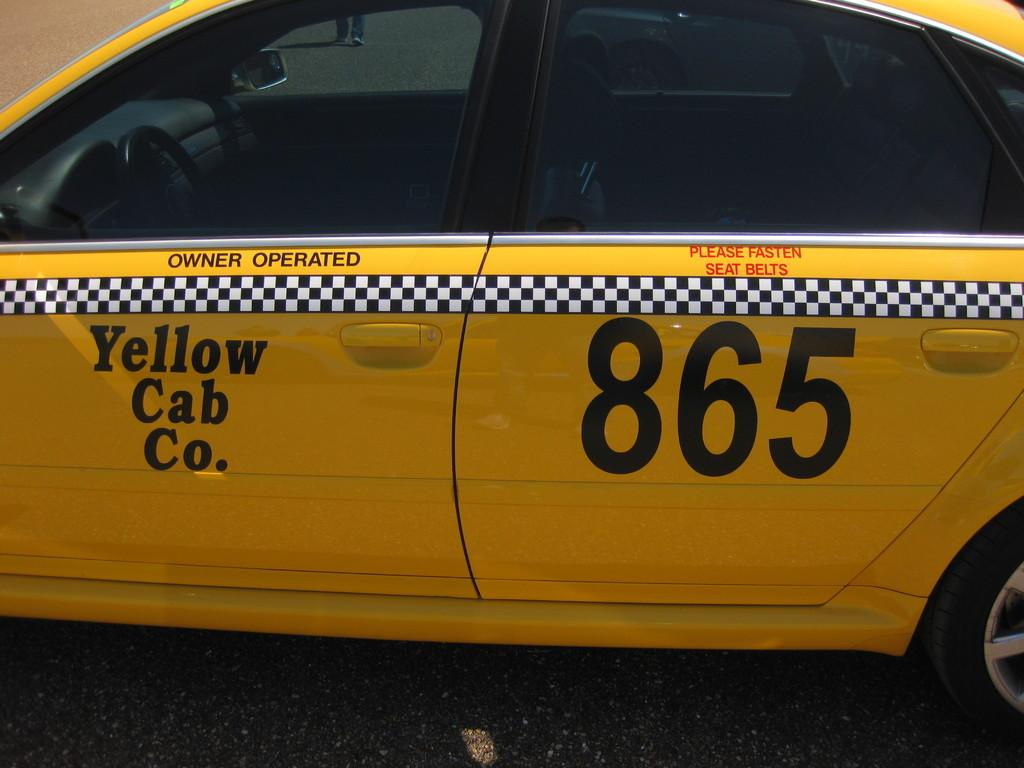Provide a one-sentence caption for the provided image. A Yellow Cab Co. 865 cab that is parked on the pavement. 